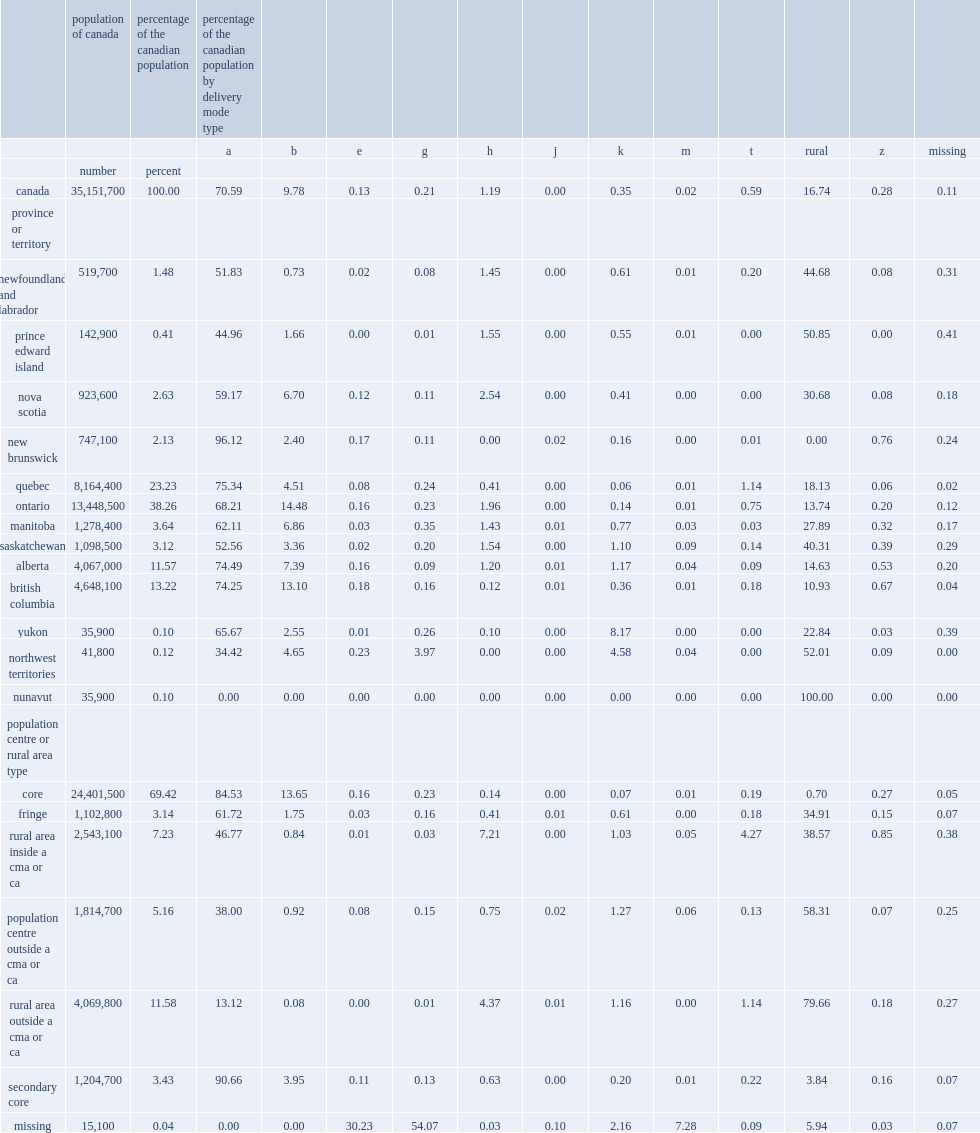What is the percentage of canadians were serviced by a dmt of type b (urban street address) in 2016? 70.59. What is the percentage of canadians were serviced by a dmt of type a (urban street address) in 2016? 9.78. What is the percentage of canadians were serviced by a dmt of rural postal code in 2016? 16.74. 